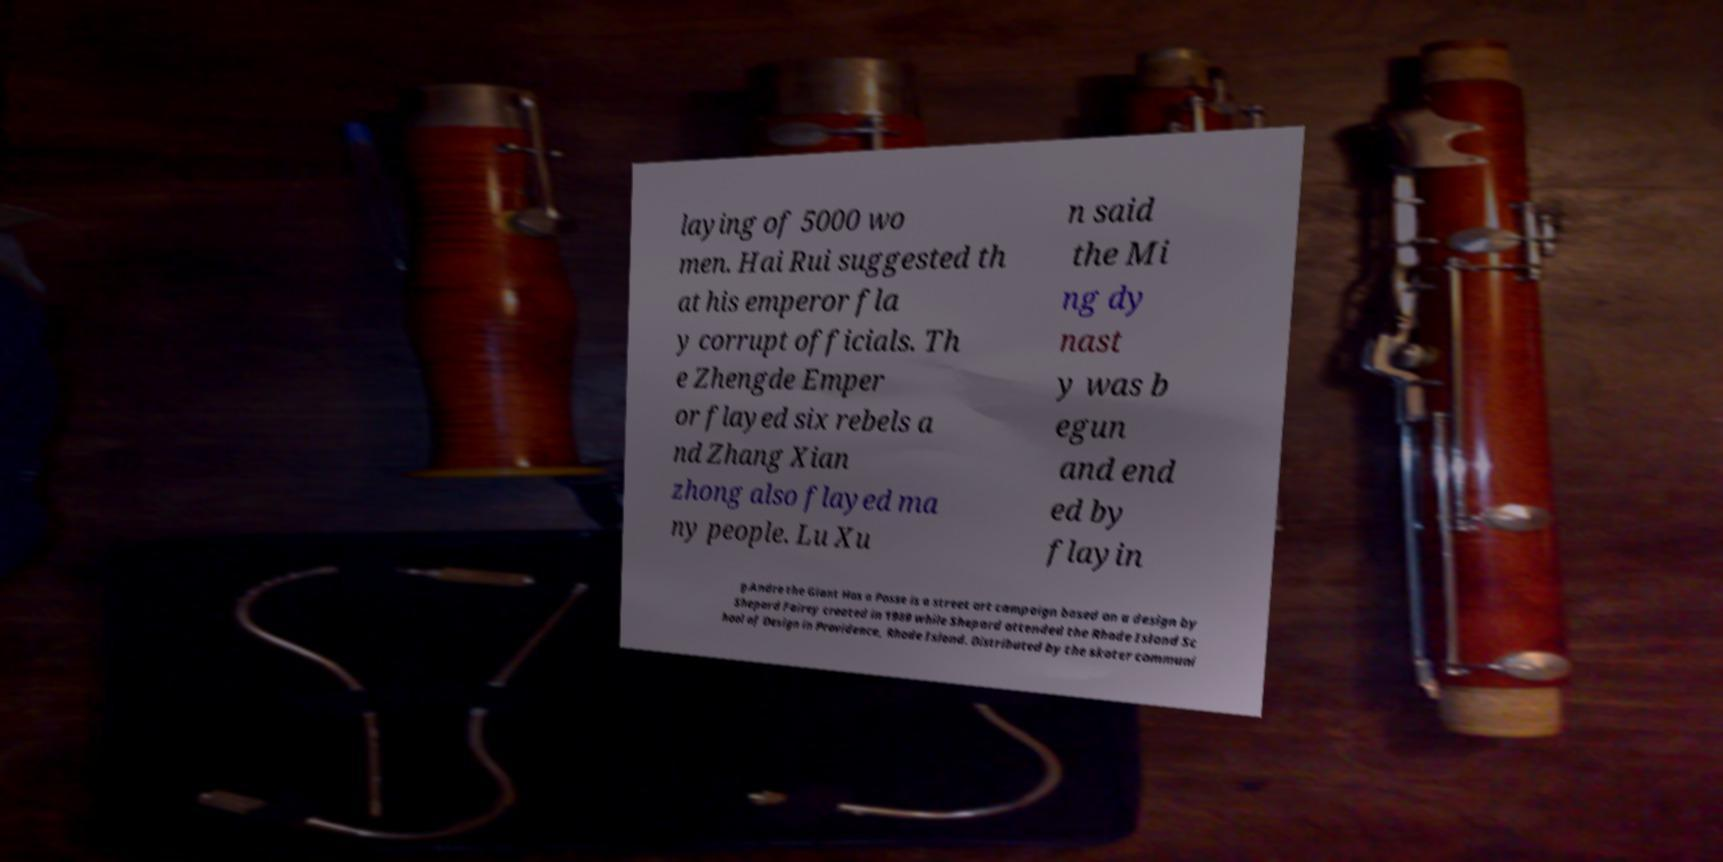Can you read and provide the text displayed in the image?This photo seems to have some interesting text. Can you extract and type it out for me? laying of 5000 wo men. Hai Rui suggested th at his emperor fla y corrupt officials. Th e Zhengde Emper or flayed six rebels a nd Zhang Xian zhong also flayed ma ny people. Lu Xu n said the Mi ng dy nast y was b egun and end ed by flayin g.Andre the Giant Has a Posse is a street art campaign based on a design by Shepard Fairey created in 1989 while Shepard attended the Rhode Island Sc hool of Design in Providence, Rhode Island. Distributed by the skater communi 